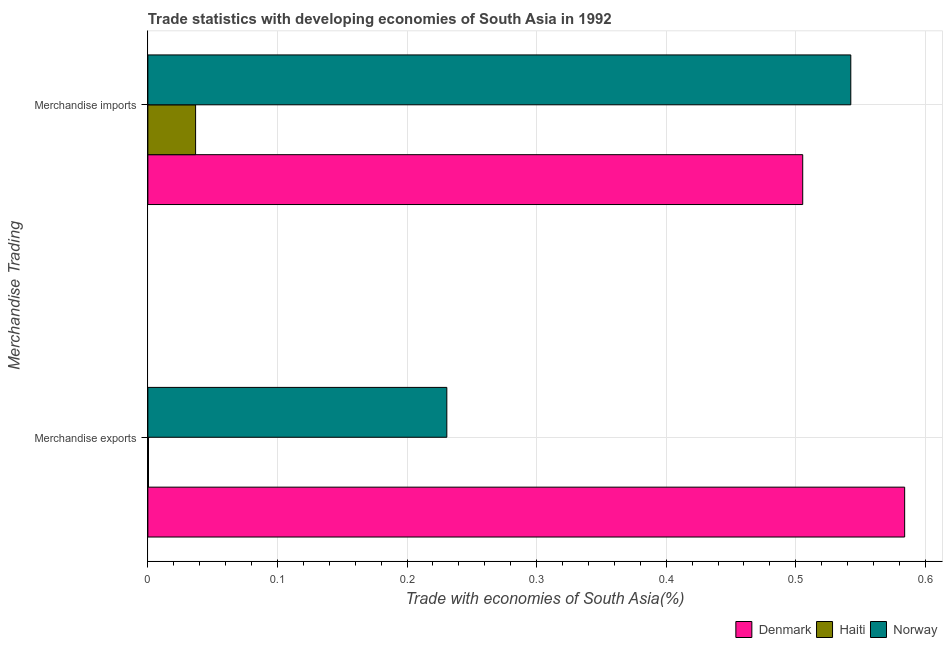How many different coloured bars are there?
Offer a very short reply. 3. How many bars are there on the 2nd tick from the bottom?
Offer a terse response. 3. What is the merchandise exports in Denmark?
Your answer should be very brief. 0.58. Across all countries, what is the maximum merchandise imports?
Provide a short and direct response. 0.54. Across all countries, what is the minimum merchandise exports?
Provide a succinct answer. 0. In which country was the merchandise exports minimum?
Offer a terse response. Haiti. What is the total merchandise imports in the graph?
Give a very brief answer. 1.08. What is the difference between the merchandise imports in Norway and that in Denmark?
Your answer should be compact. 0.04. What is the difference between the merchandise exports in Norway and the merchandise imports in Haiti?
Offer a terse response. 0.19. What is the average merchandise exports per country?
Ensure brevity in your answer.  0.27. What is the difference between the merchandise imports and merchandise exports in Denmark?
Your answer should be compact. -0.08. In how many countries, is the merchandise imports greater than 0.18 %?
Provide a succinct answer. 2. What is the ratio of the merchandise exports in Denmark to that in Haiti?
Provide a succinct answer. 1206.19. In how many countries, is the merchandise imports greater than the average merchandise imports taken over all countries?
Give a very brief answer. 2. How many bars are there?
Offer a very short reply. 6. Are all the bars in the graph horizontal?
Provide a succinct answer. Yes. How many countries are there in the graph?
Provide a succinct answer. 3. What is the difference between two consecutive major ticks on the X-axis?
Your answer should be very brief. 0.1. How many legend labels are there?
Provide a succinct answer. 3. How are the legend labels stacked?
Make the answer very short. Horizontal. What is the title of the graph?
Provide a short and direct response. Trade statistics with developing economies of South Asia in 1992. Does "Zambia" appear as one of the legend labels in the graph?
Keep it short and to the point. No. What is the label or title of the X-axis?
Your answer should be very brief. Trade with economies of South Asia(%). What is the label or title of the Y-axis?
Provide a short and direct response. Merchandise Trading. What is the Trade with economies of South Asia(%) of Denmark in Merchandise exports?
Provide a succinct answer. 0.58. What is the Trade with economies of South Asia(%) in Haiti in Merchandise exports?
Keep it short and to the point. 0. What is the Trade with economies of South Asia(%) of Norway in Merchandise exports?
Provide a succinct answer. 0.23. What is the Trade with economies of South Asia(%) of Denmark in Merchandise imports?
Keep it short and to the point. 0.51. What is the Trade with economies of South Asia(%) of Haiti in Merchandise imports?
Offer a very short reply. 0.04. What is the Trade with economies of South Asia(%) of Norway in Merchandise imports?
Your answer should be compact. 0.54. Across all Merchandise Trading, what is the maximum Trade with economies of South Asia(%) of Denmark?
Your answer should be compact. 0.58. Across all Merchandise Trading, what is the maximum Trade with economies of South Asia(%) of Haiti?
Give a very brief answer. 0.04. Across all Merchandise Trading, what is the maximum Trade with economies of South Asia(%) of Norway?
Offer a terse response. 0.54. Across all Merchandise Trading, what is the minimum Trade with economies of South Asia(%) in Denmark?
Provide a short and direct response. 0.51. Across all Merchandise Trading, what is the minimum Trade with economies of South Asia(%) of Haiti?
Give a very brief answer. 0. Across all Merchandise Trading, what is the minimum Trade with economies of South Asia(%) in Norway?
Keep it short and to the point. 0.23. What is the total Trade with economies of South Asia(%) in Denmark in the graph?
Your response must be concise. 1.09. What is the total Trade with economies of South Asia(%) of Haiti in the graph?
Give a very brief answer. 0.04. What is the total Trade with economies of South Asia(%) of Norway in the graph?
Give a very brief answer. 0.77. What is the difference between the Trade with economies of South Asia(%) of Denmark in Merchandise exports and that in Merchandise imports?
Your answer should be very brief. 0.08. What is the difference between the Trade with economies of South Asia(%) in Haiti in Merchandise exports and that in Merchandise imports?
Ensure brevity in your answer.  -0.04. What is the difference between the Trade with economies of South Asia(%) in Norway in Merchandise exports and that in Merchandise imports?
Your answer should be compact. -0.31. What is the difference between the Trade with economies of South Asia(%) of Denmark in Merchandise exports and the Trade with economies of South Asia(%) of Haiti in Merchandise imports?
Your answer should be very brief. 0.55. What is the difference between the Trade with economies of South Asia(%) in Denmark in Merchandise exports and the Trade with economies of South Asia(%) in Norway in Merchandise imports?
Provide a succinct answer. 0.04. What is the difference between the Trade with economies of South Asia(%) of Haiti in Merchandise exports and the Trade with economies of South Asia(%) of Norway in Merchandise imports?
Make the answer very short. -0.54. What is the average Trade with economies of South Asia(%) of Denmark per Merchandise Trading?
Your answer should be very brief. 0.54. What is the average Trade with economies of South Asia(%) in Haiti per Merchandise Trading?
Your answer should be compact. 0.02. What is the average Trade with economies of South Asia(%) in Norway per Merchandise Trading?
Offer a terse response. 0.39. What is the difference between the Trade with economies of South Asia(%) of Denmark and Trade with economies of South Asia(%) of Haiti in Merchandise exports?
Your answer should be very brief. 0.58. What is the difference between the Trade with economies of South Asia(%) in Denmark and Trade with economies of South Asia(%) in Norway in Merchandise exports?
Make the answer very short. 0.35. What is the difference between the Trade with economies of South Asia(%) in Haiti and Trade with economies of South Asia(%) in Norway in Merchandise exports?
Your response must be concise. -0.23. What is the difference between the Trade with economies of South Asia(%) in Denmark and Trade with economies of South Asia(%) in Haiti in Merchandise imports?
Offer a terse response. 0.47. What is the difference between the Trade with economies of South Asia(%) in Denmark and Trade with economies of South Asia(%) in Norway in Merchandise imports?
Offer a terse response. -0.04. What is the difference between the Trade with economies of South Asia(%) in Haiti and Trade with economies of South Asia(%) in Norway in Merchandise imports?
Your answer should be very brief. -0.51. What is the ratio of the Trade with economies of South Asia(%) in Denmark in Merchandise exports to that in Merchandise imports?
Keep it short and to the point. 1.16. What is the ratio of the Trade with economies of South Asia(%) of Haiti in Merchandise exports to that in Merchandise imports?
Offer a very short reply. 0.01. What is the ratio of the Trade with economies of South Asia(%) of Norway in Merchandise exports to that in Merchandise imports?
Give a very brief answer. 0.43. What is the difference between the highest and the second highest Trade with economies of South Asia(%) in Denmark?
Ensure brevity in your answer.  0.08. What is the difference between the highest and the second highest Trade with economies of South Asia(%) in Haiti?
Your answer should be very brief. 0.04. What is the difference between the highest and the second highest Trade with economies of South Asia(%) in Norway?
Ensure brevity in your answer.  0.31. What is the difference between the highest and the lowest Trade with economies of South Asia(%) in Denmark?
Offer a terse response. 0.08. What is the difference between the highest and the lowest Trade with economies of South Asia(%) in Haiti?
Give a very brief answer. 0.04. What is the difference between the highest and the lowest Trade with economies of South Asia(%) in Norway?
Provide a short and direct response. 0.31. 